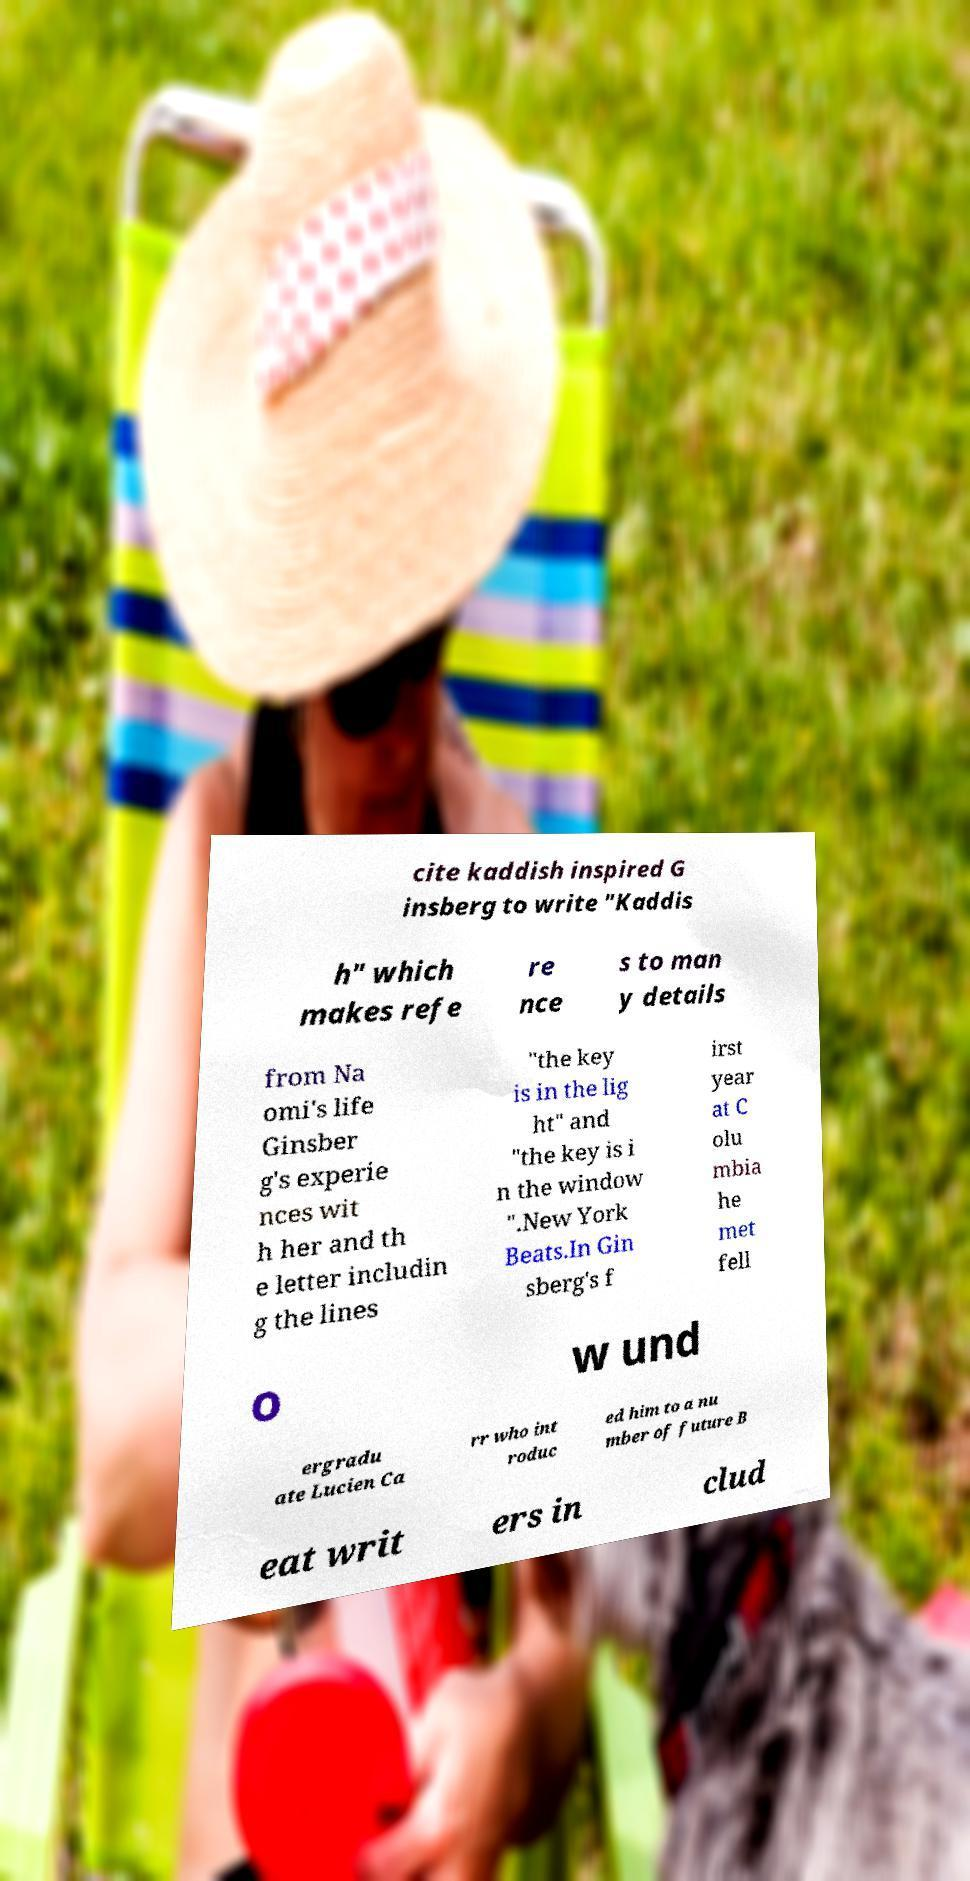What messages or text are displayed in this image? I need them in a readable, typed format. cite kaddish inspired G insberg to write "Kaddis h" which makes refe re nce s to man y details from Na omi's life Ginsber g's experie nces wit h her and th e letter includin g the lines "the key is in the lig ht" and "the key is i n the window ".New York Beats.In Gin sberg's f irst year at C olu mbia he met fell o w und ergradu ate Lucien Ca rr who int roduc ed him to a nu mber of future B eat writ ers in clud 